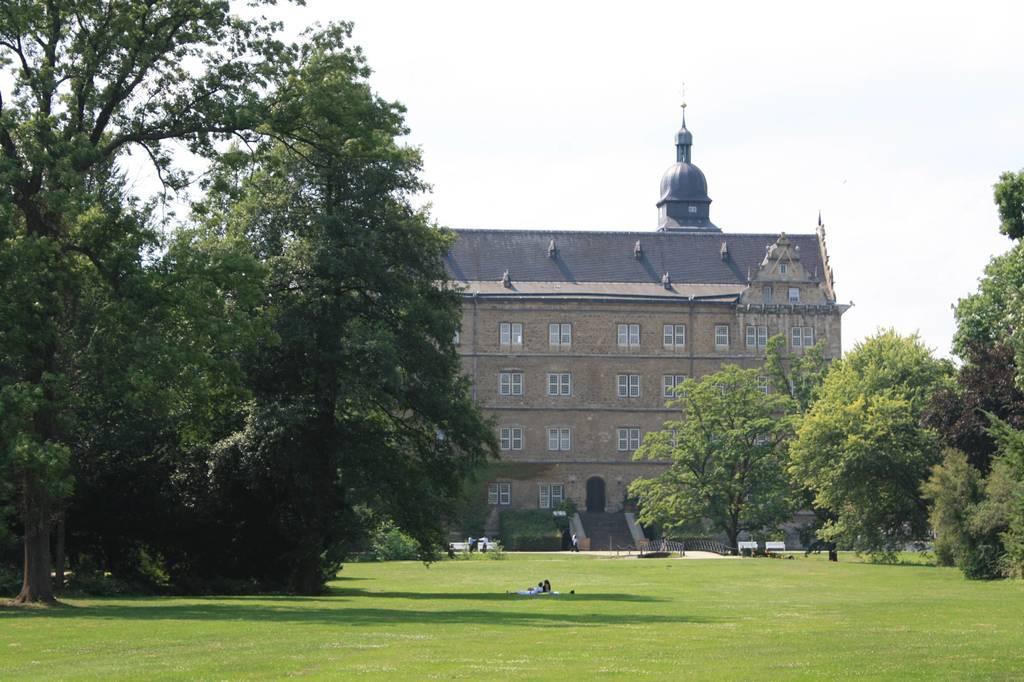In one or two sentences, can you explain what this image depicts? In this image there is a garden, on left side and right side there are trees, in the background there is a building and a sky. 